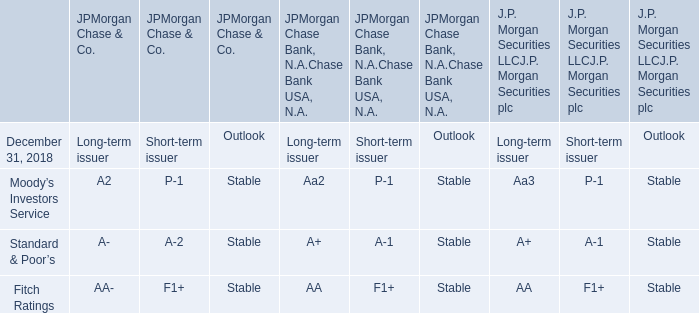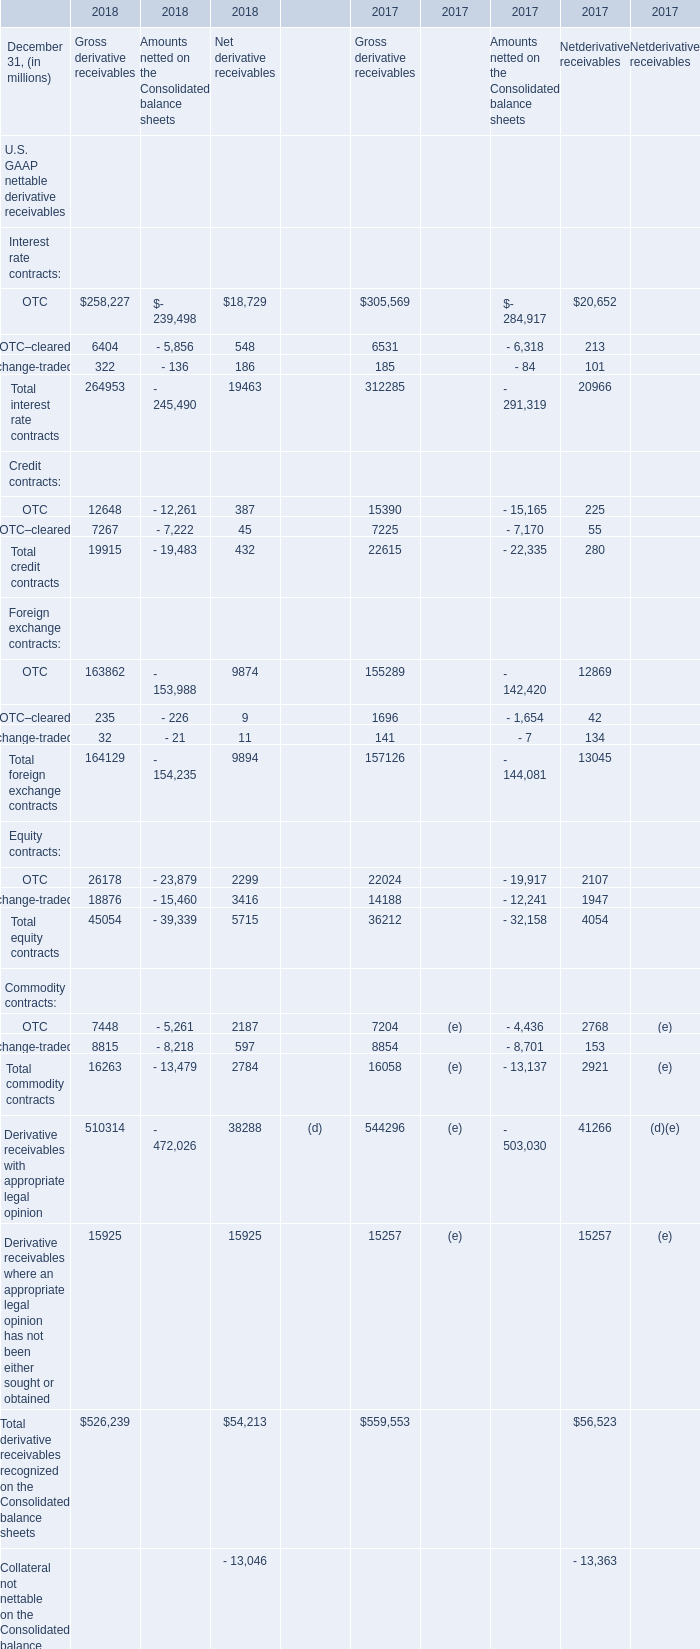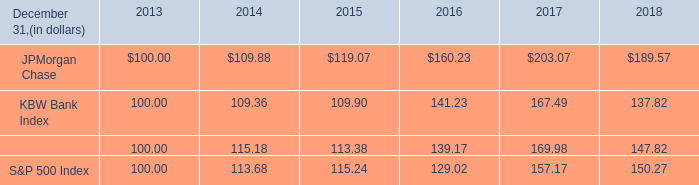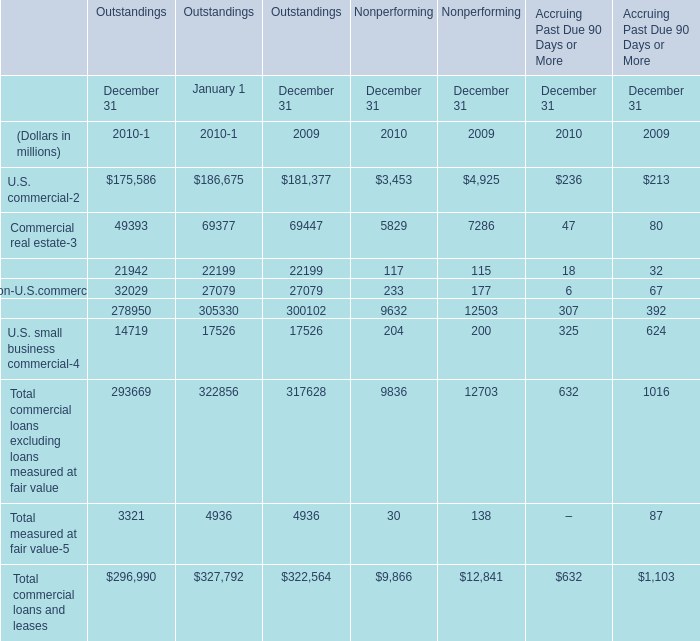What's the difference of Commercial lease financing between 2009 and 2010? (in million) 
Computations: (21942 - 22199)
Answer: -257.0. 